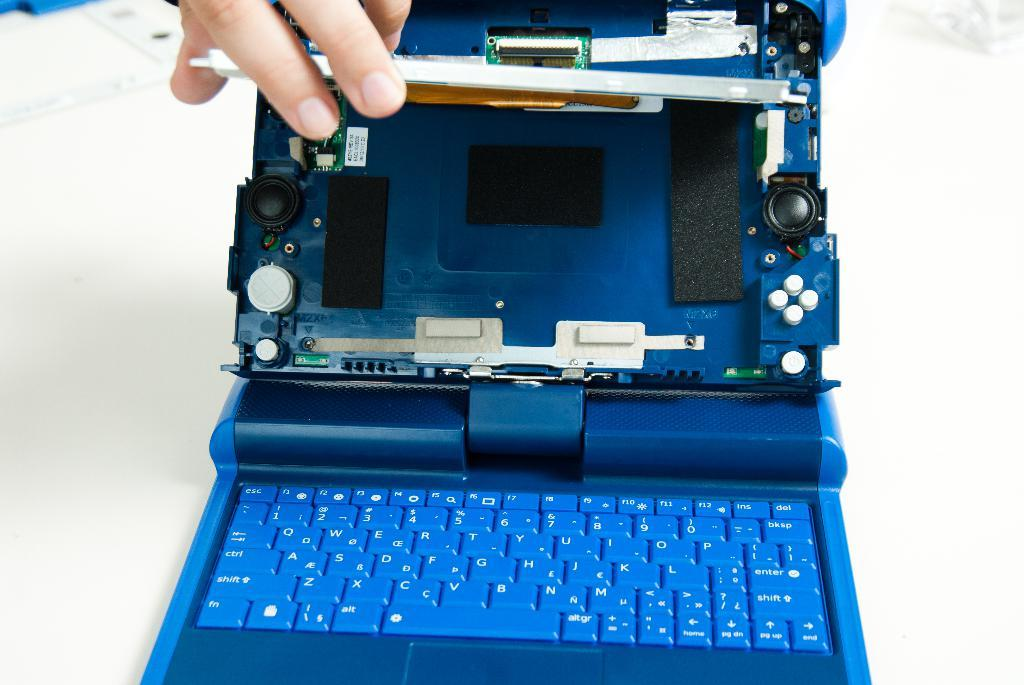<image>
Render a clear and concise summary of the photo. A town down laptop display shows what is behind the screen along with a keyboard that includes Enter and Shift keys. 